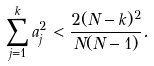Convert formula to latex. <formula><loc_0><loc_0><loc_500><loc_500>\sum _ { j = 1 } ^ { k } a ^ { 2 } _ { j } < \frac { 2 ( N - k ) ^ { 2 } } { N ( N - 1 ) } .</formula> 